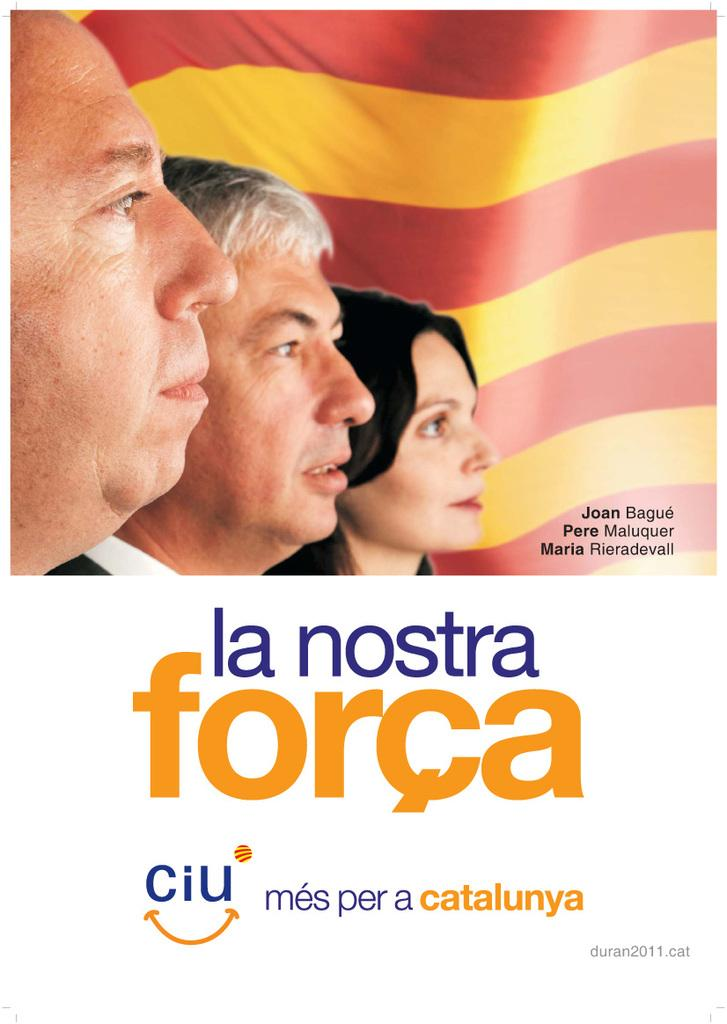What is featured in the picture? There is a poster in the picture. What can be seen on the poster? The poster contains pictures of three people. Are there any labels or identifiers on the poster? Yes, there are names associated with the pictures on the poster. What flavor of owl can be seen in the picture? There is no owl present in the picture; it features a poster with pictures of three people and their names. 